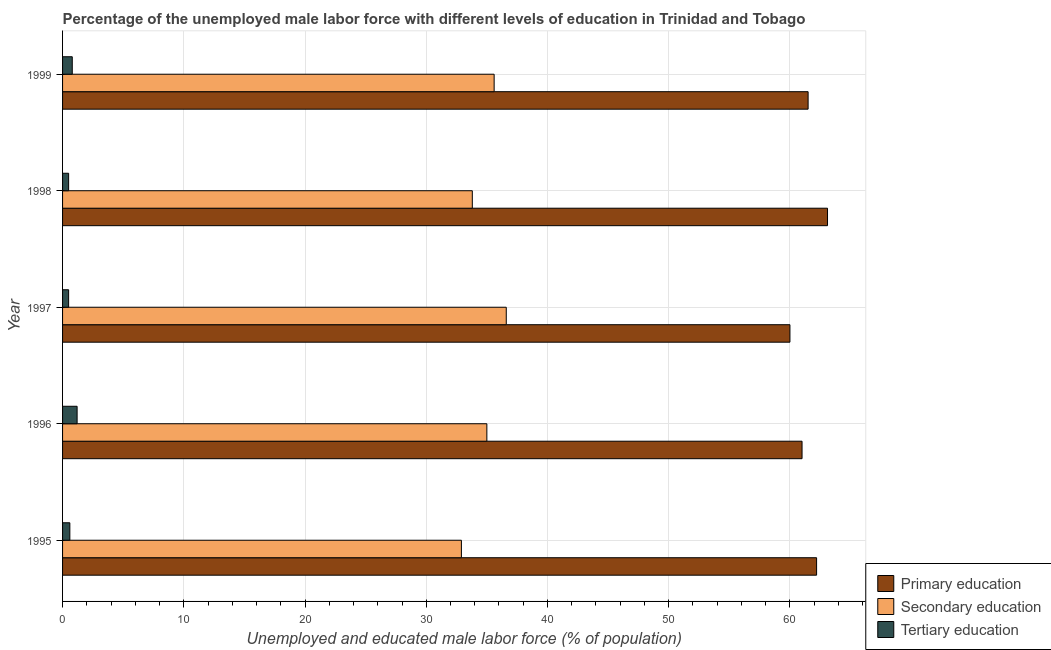How many groups of bars are there?
Provide a short and direct response. 5. How many bars are there on the 4th tick from the bottom?
Offer a very short reply. 3. What is the label of the 4th group of bars from the top?
Make the answer very short. 1996. In how many cases, is the number of bars for a given year not equal to the number of legend labels?
Keep it short and to the point. 0. What is the percentage of male labor force who received tertiary education in 1998?
Provide a succinct answer. 0.5. Across all years, what is the maximum percentage of male labor force who received primary education?
Offer a very short reply. 63.1. What is the total percentage of male labor force who received primary education in the graph?
Your answer should be compact. 307.8. What is the difference between the percentage of male labor force who received primary education in 1997 and the percentage of male labor force who received secondary education in 1998?
Offer a very short reply. 26.2. What is the average percentage of male labor force who received secondary education per year?
Offer a terse response. 34.78. In the year 1995, what is the difference between the percentage of male labor force who received primary education and percentage of male labor force who received secondary education?
Keep it short and to the point. 29.3. Is the percentage of male labor force who received tertiary education in 1997 less than that in 1999?
Ensure brevity in your answer.  Yes. Is the sum of the percentage of male labor force who received secondary education in 1996 and 1999 greater than the maximum percentage of male labor force who received primary education across all years?
Offer a very short reply. Yes. What does the 1st bar from the top in 1995 represents?
Give a very brief answer. Tertiary education. What does the 3rd bar from the bottom in 1999 represents?
Provide a succinct answer. Tertiary education. Is it the case that in every year, the sum of the percentage of male labor force who received primary education and percentage of male labor force who received secondary education is greater than the percentage of male labor force who received tertiary education?
Offer a very short reply. Yes. How many bars are there?
Your answer should be very brief. 15. Are all the bars in the graph horizontal?
Give a very brief answer. Yes. How many years are there in the graph?
Offer a very short reply. 5. Does the graph contain grids?
Provide a succinct answer. Yes. Where does the legend appear in the graph?
Keep it short and to the point. Bottom right. What is the title of the graph?
Ensure brevity in your answer.  Percentage of the unemployed male labor force with different levels of education in Trinidad and Tobago. Does "Infant(male)" appear as one of the legend labels in the graph?
Your response must be concise. No. What is the label or title of the X-axis?
Your answer should be very brief. Unemployed and educated male labor force (% of population). What is the label or title of the Y-axis?
Your answer should be compact. Year. What is the Unemployed and educated male labor force (% of population) in Primary education in 1995?
Ensure brevity in your answer.  62.2. What is the Unemployed and educated male labor force (% of population) of Secondary education in 1995?
Your answer should be compact. 32.9. What is the Unemployed and educated male labor force (% of population) in Tertiary education in 1995?
Ensure brevity in your answer.  0.6. What is the Unemployed and educated male labor force (% of population) in Secondary education in 1996?
Provide a succinct answer. 35. What is the Unemployed and educated male labor force (% of population) in Tertiary education in 1996?
Provide a short and direct response. 1.2. What is the Unemployed and educated male labor force (% of population) of Primary education in 1997?
Give a very brief answer. 60. What is the Unemployed and educated male labor force (% of population) of Secondary education in 1997?
Keep it short and to the point. 36.6. What is the Unemployed and educated male labor force (% of population) in Primary education in 1998?
Your answer should be compact. 63.1. What is the Unemployed and educated male labor force (% of population) in Secondary education in 1998?
Your answer should be very brief. 33.8. What is the Unemployed and educated male labor force (% of population) in Primary education in 1999?
Offer a very short reply. 61.5. What is the Unemployed and educated male labor force (% of population) of Secondary education in 1999?
Make the answer very short. 35.6. What is the Unemployed and educated male labor force (% of population) of Tertiary education in 1999?
Your response must be concise. 0.8. Across all years, what is the maximum Unemployed and educated male labor force (% of population) in Primary education?
Offer a terse response. 63.1. Across all years, what is the maximum Unemployed and educated male labor force (% of population) in Secondary education?
Offer a terse response. 36.6. Across all years, what is the maximum Unemployed and educated male labor force (% of population) in Tertiary education?
Provide a succinct answer. 1.2. Across all years, what is the minimum Unemployed and educated male labor force (% of population) of Secondary education?
Offer a very short reply. 32.9. What is the total Unemployed and educated male labor force (% of population) of Primary education in the graph?
Your response must be concise. 307.8. What is the total Unemployed and educated male labor force (% of population) in Secondary education in the graph?
Offer a very short reply. 173.9. What is the difference between the Unemployed and educated male labor force (% of population) in Secondary education in 1995 and that in 1996?
Provide a short and direct response. -2.1. What is the difference between the Unemployed and educated male labor force (% of population) of Primary education in 1995 and that in 1997?
Keep it short and to the point. 2.2. What is the difference between the Unemployed and educated male labor force (% of population) in Secondary education in 1995 and that in 1997?
Provide a short and direct response. -3.7. What is the difference between the Unemployed and educated male labor force (% of population) in Primary education in 1995 and that in 1998?
Your answer should be very brief. -0.9. What is the difference between the Unemployed and educated male labor force (% of population) in Tertiary education in 1995 and that in 1998?
Keep it short and to the point. 0.1. What is the difference between the Unemployed and educated male labor force (% of population) of Primary education in 1995 and that in 1999?
Ensure brevity in your answer.  0.7. What is the difference between the Unemployed and educated male labor force (% of population) of Secondary education in 1995 and that in 1999?
Offer a very short reply. -2.7. What is the difference between the Unemployed and educated male labor force (% of population) in Tertiary education in 1995 and that in 1999?
Keep it short and to the point. -0.2. What is the difference between the Unemployed and educated male labor force (% of population) of Primary education in 1996 and that in 1998?
Provide a short and direct response. -2.1. What is the difference between the Unemployed and educated male labor force (% of population) of Tertiary education in 1996 and that in 1998?
Make the answer very short. 0.7. What is the difference between the Unemployed and educated male labor force (% of population) in Primary education in 1996 and that in 1999?
Ensure brevity in your answer.  -0.5. What is the difference between the Unemployed and educated male labor force (% of population) in Tertiary education in 1996 and that in 1999?
Your answer should be very brief. 0.4. What is the difference between the Unemployed and educated male labor force (% of population) in Primary education in 1997 and that in 1998?
Your answer should be very brief. -3.1. What is the difference between the Unemployed and educated male labor force (% of population) of Secondary education in 1997 and that in 1998?
Offer a terse response. 2.8. What is the difference between the Unemployed and educated male labor force (% of population) of Primary education in 1998 and that in 1999?
Offer a terse response. 1.6. What is the difference between the Unemployed and educated male labor force (% of population) of Secondary education in 1998 and that in 1999?
Provide a short and direct response. -1.8. What is the difference between the Unemployed and educated male labor force (% of population) of Primary education in 1995 and the Unemployed and educated male labor force (% of population) of Secondary education in 1996?
Give a very brief answer. 27.2. What is the difference between the Unemployed and educated male labor force (% of population) of Primary education in 1995 and the Unemployed and educated male labor force (% of population) of Tertiary education in 1996?
Your response must be concise. 61. What is the difference between the Unemployed and educated male labor force (% of population) in Secondary education in 1995 and the Unemployed and educated male labor force (% of population) in Tertiary education in 1996?
Your answer should be compact. 31.7. What is the difference between the Unemployed and educated male labor force (% of population) of Primary education in 1995 and the Unemployed and educated male labor force (% of population) of Secondary education in 1997?
Give a very brief answer. 25.6. What is the difference between the Unemployed and educated male labor force (% of population) of Primary education in 1995 and the Unemployed and educated male labor force (% of population) of Tertiary education in 1997?
Ensure brevity in your answer.  61.7. What is the difference between the Unemployed and educated male labor force (% of population) in Secondary education in 1995 and the Unemployed and educated male labor force (% of population) in Tertiary education in 1997?
Make the answer very short. 32.4. What is the difference between the Unemployed and educated male labor force (% of population) in Primary education in 1995 and the Unemployed and educated male labor force (% of population) in Secondary education in 1998?
Your answer should be compact. 28.4. What is the difference between the Unemployed and educated male labor force (% of population) in Primary education in 1995 and the Unemployed and educated male labor force (% of population) in Tertiary education in 1998?
Offer a terse response. 61.7. What is the difference between the Unemployed and educated male labor force (% of population) in Secondary education in 1995 and the Unemployed and educated male labor force (% of population) in Tertiary education in 1998?
Make the answer very short. 32.4. What is the difference between the Unemployed and educated male labor force (% of population) in Primary education in 1995 and the Unemployed and educated male labor force (% of population) in Secondary education in 1999?
Your response must be concise. 26.6. What is the difference between the Unemployed and educated male labor force (% of population) of Primary education in 1995 and the Unemployed and educated male labor force (% of population) of Tertiary education in 1999?
Offer a terse response. 61.4. What is the difference between the Unemployed and educated male labor force (% of population) of Secondary education in 1995 and the Unemployed and educated male labor force (% of population) of Tertiary education in 1999?
Provide a succinct answer. 32.1. What is the difference between the Unemployed and educated male labor force (% of population) in Primary education in 1996 and the Unemployed and educated male labor force (% of population) in Secondary education in 1997?
Keep it short and to the point. 24.4. What is the difference between the Unemployed and educated male labor force (% of population) in Primary education in 1996 and the Unemployed and educated male labor force (% of population) in Tertiary education in 1997?
Keep it short and to the point. 60.5. What is the difference between the Unemployed and educated male labor force (% of population) of Secondary education in 1996 and the Unemployed and educated male labor force (% of population) of Tertiary education in 1997?
Your answer should be compact. 34.5. What is the difference between the Unemployed and educated male labor force (% of population) in Primary education in 1996 and the Unemployed and educated male labor force (% of population) in Secondary education in 1998?
Offer a very short reply. 27.2. What is the difference between the Unemployed and educated male labor force (% of population) in Primary education in 1996 and the Unemployed and educated male labor force (% of population) in Tertiary education in 1998?
Your answer should be compact. 60.5. What is the difference between the Unemployed and educated male labor force (% of population) of Secondary education in 1996 and the Unemployed and educated male labor force (% of population) of Tertiary education in 1998?
Give a very brief answer. 34.5. What is the difference between the Unemployed and educated male labor force (% of population) of Primary education in 1996 and the Unemployed and educated male labor force (% of population) of Secondary education in 1999?
Give a very brief answer. 25.4. What is the difference between the Unemployed and educated male labor force (% of population) of Primary education in 1996 and the Unemployed and educated male labor force (% of population) of Tertiary education in 1999?
Make the answer very short. 60.2. What is the difference between the Unemployed and educated male labor force (% of population) of Secondary education in 1996 and the Unemployed and educated male labor force (% of population) of Tertiary education in 1999?
Offer a very short reply. 34.2. What is the difference between the Unemployed and educated male labor force (% of population) in Primary education in 1997 and the Unemployed and educated male labor force (% of population) in Secondary education in 1998?
Offer a terse response. 26.2. What is the difference between the Unemployed and educated male labor force (% of population) in Primary education in 1997 and the Unemployed and educated male labor force (% of population) in Tertiary education in 1998?
Offer a very short reply. 59.5. What is the difference between the Unemployed and educated male labor force (% of population) of Secondary education in 1997 and the Unemployed and educated male labor force (% of population) of Tertiary education in 1998?
Offer a very short reply. 36.1. What is the difference between the Unemployed and educated male labor force (% of population) of Primary education in 1997 and the Unemployed and educated male labor force (% of population) of Secondary education in 1999?
Your response must be concise. 24.4. What is the difference between the Unemployed and educated male labor force (% of population) of Primary education in 1997 and the Unemployed and educated male labor force (% of population) of Tertiary education in 1999?
Your answer should be compact. 59.2. What is the difference between the Unemployed and educated male labor force (% of population) in Secondary education in 1997 and the Unemployed and educated male labor force (% of population) in Tertiary education in 1999?
Provide a short and direct response. 35.8. What is the difference between the Unemployed and educated male labor force (% of population) in Primary education in 1998 and the Unemployed and educated male labor force (% of population) in Tertiary education in 1999?
Offer a terse response. 62.3. What is the average Unemployed and educated male labor force (% of population) in Primary education per year?
Your answer should be very brief. 61.56. What is the average Unemployed and educated male labor force (% of population) of Secondary education per year?
Offer a terse response. 34.78. What is the average Unemployed and educated male labor force (% of population) of Tertiary education per year?
Your answer should be very brief. 0.72. In the year 1995, what is the difference between the Unemployed and educated male labor force (% of population) of Primary education and Unemployed and educated male labor force (% of population) of Secondary education?
Make the answer very short. 29.3. In the year 1995, what is the difference between the Unemployed and educated male labor force (% of population) of Primary education and Unemployed and educated male labor force (% of population) of Tertiary education?
Keep it short and to the point. 61.6. In the year 1995, what is the difference between the Unemployed and educated male labor force (% of population) in Secondary education and Unemployed and educated male labor force (% of population) in Tertiary education?
Provide a succinct answer. 32.3. In the year 1996, what is the difference between the Unemployed and educated male labor force (% of population) of Primary education and Unemployed and educated male labor force (% of population) of Tertiary education?
Your answer should be compact. 59.8. In the year 1996, what is the difference between the Unemployed and educated male labor force (% of population) in Secondary education and Unemployed and educated male labor force (% of population) in Tertiary education?
Offer a terse response. 33.8. In the year 1997, what is the difference between the Unemployed and educated male labor force (% of population) in Primary education and Unemployed and educated male labor force (% of population) in Secondary education?
Your answer should be compact. 23.4. In the year 1997, what is the difference between the Unemployed and educated male labor force (% of population) of Primary education and Unemployed and educated male labor force (% of population) of Tertiary education?
Your answer should be compact. 59.5. In the year 1997, what is the difference between the Unemployed and educated male labor force (% of population) of Secondary education and Unemployed and educated male labor force (% of population) of Tertiary education?
Give a very brief answer. 36.1. In the year 1998, what is the difference between the Unemployed and educated male labor force (% of population) in Primary education and Unemployed and educated male labor force (% of population) in Secondary education?
Ensure brevity in your answer.  29.3. In the year 1998, what is the difference between the Unemployed and educated male labor force (% of population) in Primary education and Unemployed and educated male labor force (% of population) in Tertiary education?
Your response must be concise. 62.6. In the year 1998, what is the difference between the Unemployed and educated male labor force (% of population) of Secondary education and Unemployed and educated male labor force (% of population) of Tertiary education?
Make the answer very short. 33.3. In the year 1999, what is the difference between the Unemployed and educated male labor force (% of population) of Primary education and Unemployed and educated male labor force (% of population) of Secondary education?
Your answer should be compact. 25.9. In the year 1999, what is the difference between the Unemployed and educated male labor force (% of population) in Primary education and Unemployed and educated male labor force (% of population) in Tertiary education?
Make the answer very short. 60.7. In the year 1999, what is the difference between the Unemployed and educated male labor force (% of population) of Secondary education and Unemployed and educated male labor force (% of population) of Tertiary education?
Your response must be concise. 34.8. What is the ratio of the Unemployed and educated male labor force (% of population) of Primary education in 1995 to that in 1996?
Your answer should be compact. 1.02. What is the ratio of the Unemployed and educated male labor force (% of population) in Secondary education in 1995 to that in 1996?
Make the answer very short. 0.94. What is the ratio of the Unemployed and educated male labor force (% of population) in Primary education in 1995 to that in 1997?
Keep it short and to the point. 1.04. What is the ratio of the Unemployed and educated male labor force (% of population) in Secondary education in 1995 to that in 1997?
Provide a succinct answer. 0.9. What is the ratio of the Unemployed and educated male labor force (% of population) of Primary education in 1995 to that in 1998?
Make the answer very short. 0.99. What is the ratio of the Unemployed and educated male labor force (% of population) of Secondary education in 1995 to that in 1998?
Offer a very short reply. 0.97. What is the ratio of the Unemployed and educated male labor force (% of population) of Tertiary education in 1995 to that in 1998?
Offer a very short reply. 1.2. What is the ratio of the Unemployed and educated male labor force (% of population) in Primary education in 1995 to that in 1999?
Offer a very short reply. 1.01. What is the ratio of the Unemployed and educated male labor force (% of population) in Secondary education in 1995 to that in 1999?
Ensure brevity in your answer.  0.92. What is the ratio of the Unemployed and educated male labor force (% of population) of Primary education in 1996 to that in 1997?
Give a very brief answer. 1.02. What is the ratio of the Unemployed and educated male labor force (% of population) in Secondary education in 1996 to that in 1997?
Provide a short and direct response. 0.96. What is the ratio of the Unemployed and educated male labor force (% of population) in Tertiary education in 1996 to that in 1997?
Offer a terse response. 2.4. What is the ratio of the Unemployed and educated male labor force (% of population) in Primary education in 1996 to that in 1998?
Provide a succinct answer. 0.97. What is the ratio of the Unemployed and educated male labor force (% of population) of Secondary education in 1996 to that in 1998?
Make the answer very short. 1.04. What is the ratio of the Unemployed and educated male labor force (% of population) of Secondary education in 1996 to that in 1999?
Provide a succinct answer. 0.98. What is the ratio of the Unemployed and educated male labor force (% of population) of Primary education in 1997 to that in 1998?
Keep it short and to the point. 0.95. What is the ratio of the Unemployed and educated male labor force (% of population) in Secondary education in 1997 to that in 1998?
Make the answer very short. 1.08. What is the ratio of the Unemployed and educated male labor force (% of population) of Tertiary education in 1997 to that in 1998?
Provide a short and direct response. 1. What is the ratio of the Unemployed and educated male labor force (% of population) of Primary education in 1997 to that in 1999?
Offer a terse response. 0.98. What is the ratio of the Unemployed and educated male labor force (% of population) of Secondary education in 1997 to that in 1999?
Provide a short and direct response. 1.03. What is the ratio of the Unemployed and educated male labor force (% of population) of Tertiary education in 1997 to that in 1999?
Provide a short and direct response. 0.62. What is the ratio of the Unemployed and educated male labor force (% of population) of Primary education in 1998 to that in 1999?
Ensure brevity in your answer.  1.03. What is the ratio of the Unemployed and educated male labor force (% of population) of Secondary education in 1998 to that in 1999?
Ensure brevity in your answer.  0.95. What is the difference between the highest and the second highest Unemployed and educated male labor force (% of population) of Primary education?
Keep it short and to the point. 0.9. What is the difference between the highest and the lowest Unemployed and educated male labor force (% of population) in Secondary education?
Provide a succinct answer. 3.7. 